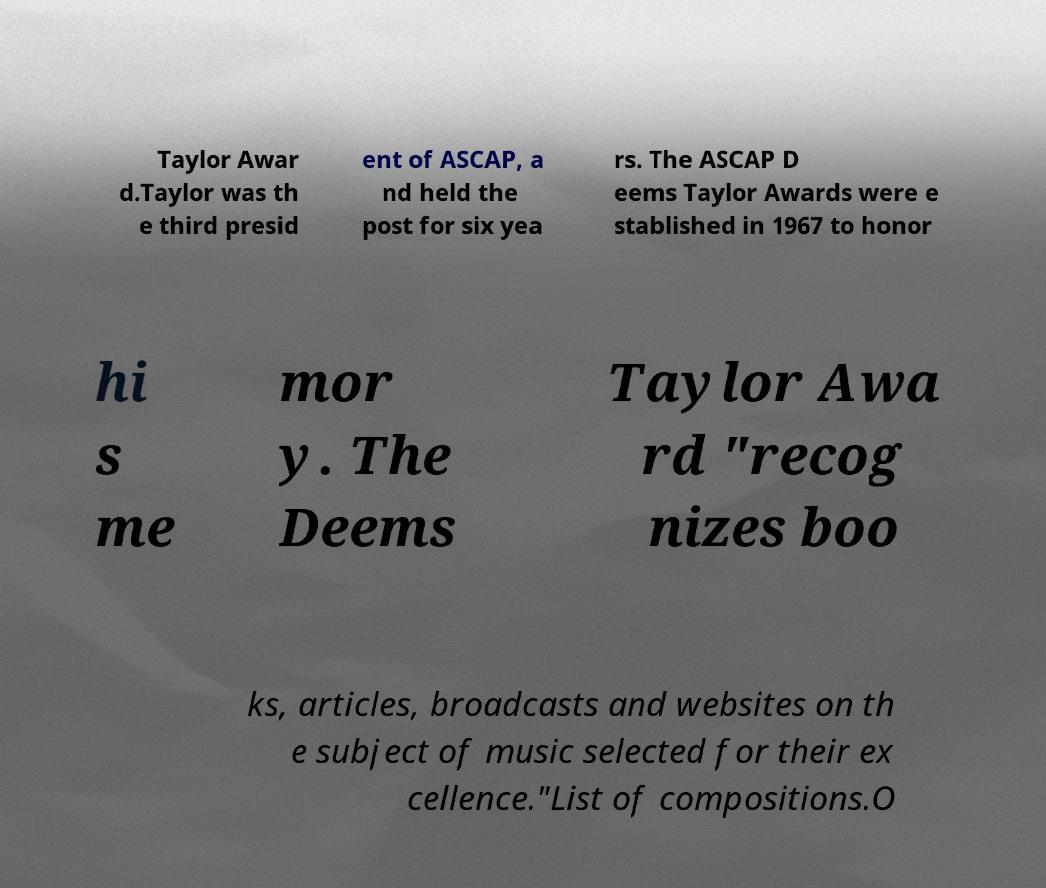Can you read and provide the text displayed in the image?This photo seems to have some interesting text. Can you extract and type it out for me? Taylor Awar d.Taylor was th e third presid ent of ASCAP, a nd held the post for six yea rs. The ASCAP D eems Taylor Awards were e stablished in 1967 to honor hi s me mor y. The Deems Taylor Awa rd "recog nizes boo ks, articles, broadcasts and websites on th e subject of music selected for their ex cellence."List of compositions.O 